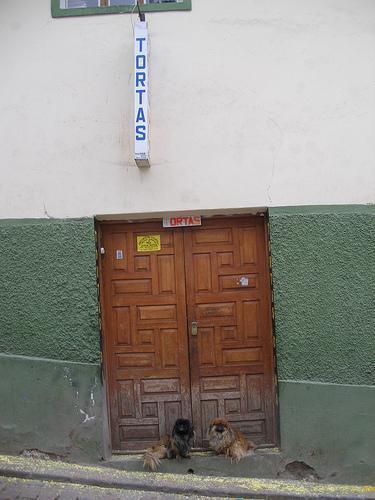How many dogs are visible in the picture?
Give a very brief answer. 3. 